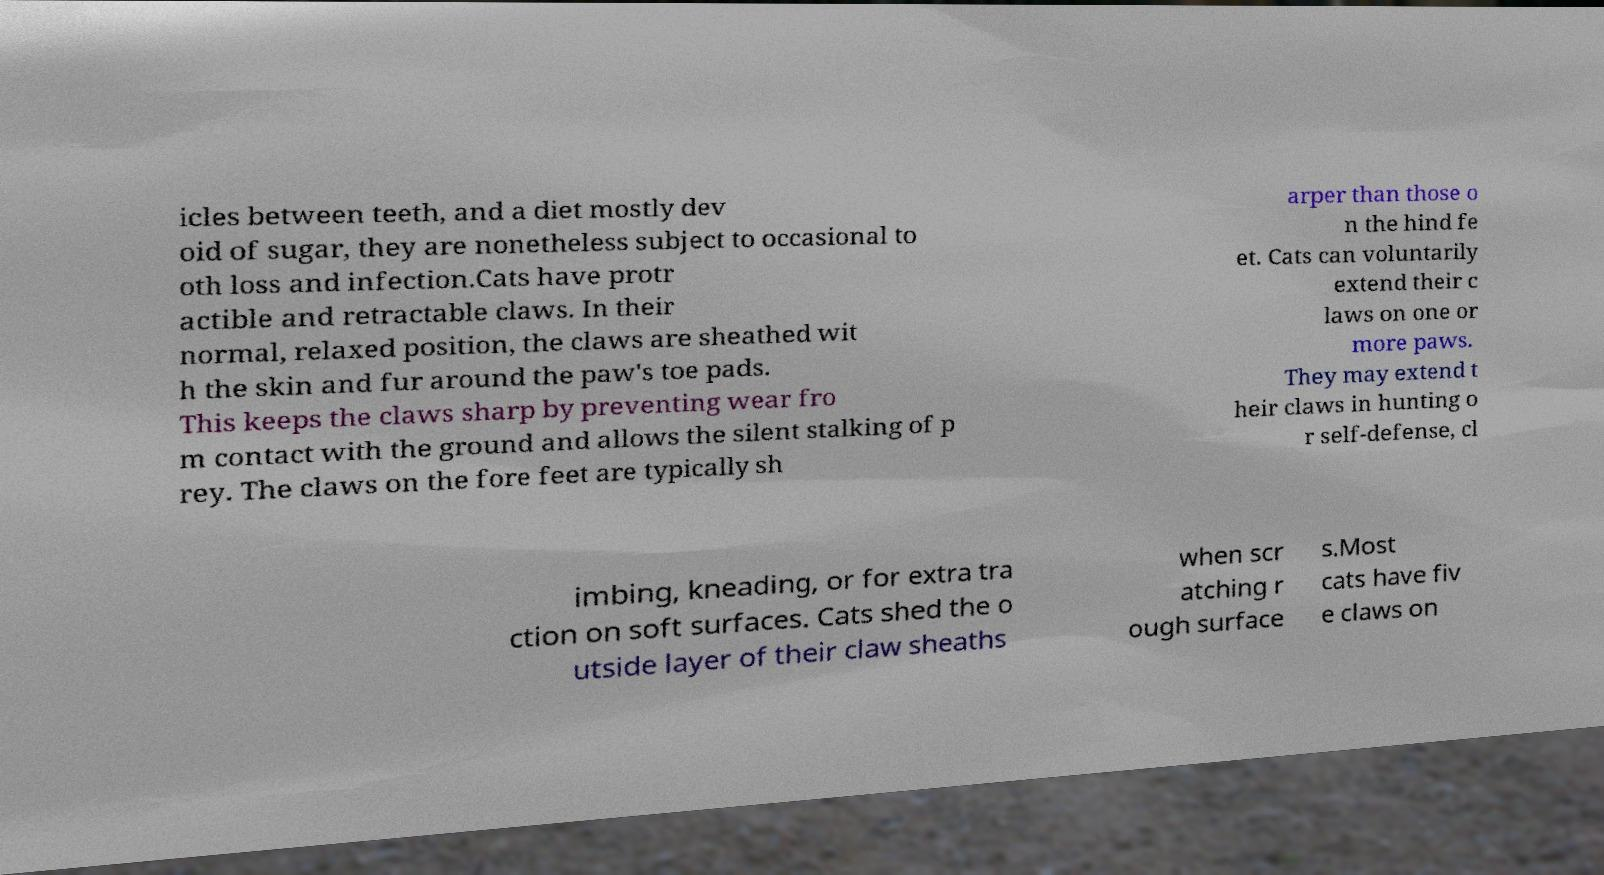What messages or text are displayed in this image? I need them in a readable, typed format. icles between teeth, and a diet mostly dev oid of sugar, they are nonetheless subject to occasional to oth loss and infection.Cats have protr actible and retractable claws. In their normal, relaxed position, the claws are sheathed wit h the skin and fur around the paw's toe pads. This keeps the claws sharp by preventing wear fro m contact with the ground and allows the silent stalking of p rey. The claws on the fore feet are typically sh arper than those o n the hind fe et. Cats can voluntarily extend their c laws on one or more paws. They may extend t heir claws in hunting o r self-defense, cl imbing, kneading, or for extra tra ction on soft surfaces. Cats shed the o utside layer of their claw sheaths when scr atching r ough surface s.Most cats have fiv e claws on 